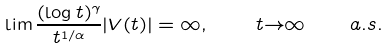Convert formula to latex. <formula><loc_0><loc_0><loc_500><loc_500>\lim { \frac { ( \log { t } ) ^ { \gamma } } { t ^ { 1 / \alpha } } | V ( t ) | } = \infty , \quad t { \to } \infty \quad a . s .</formula> 